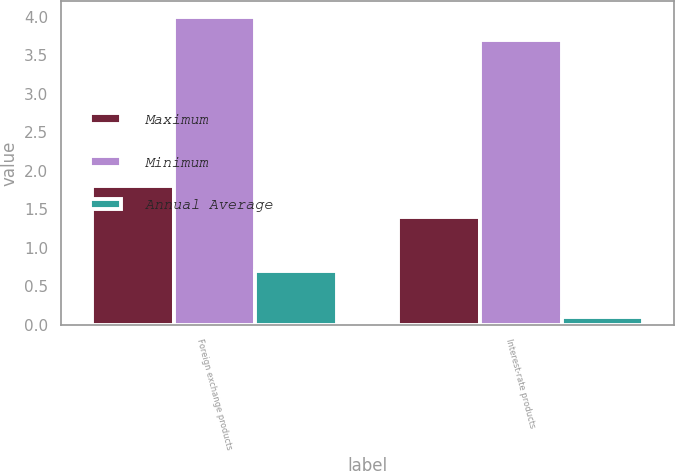Convert chart. <chart><loc_0><loc_0><loc_500><loc_500><stacked_bar_chart><ecel><fcel>Foreign exchange products<fcel>Interest-rate products<nl><fcel>Maximum<fcel>1.8<fcel>1.4<nl><fcel>Minimum<fcel>4<fcel>3.7<nl><fcel>Annual Average<fcel>0.7<fcel>0.1<nl></chart> 